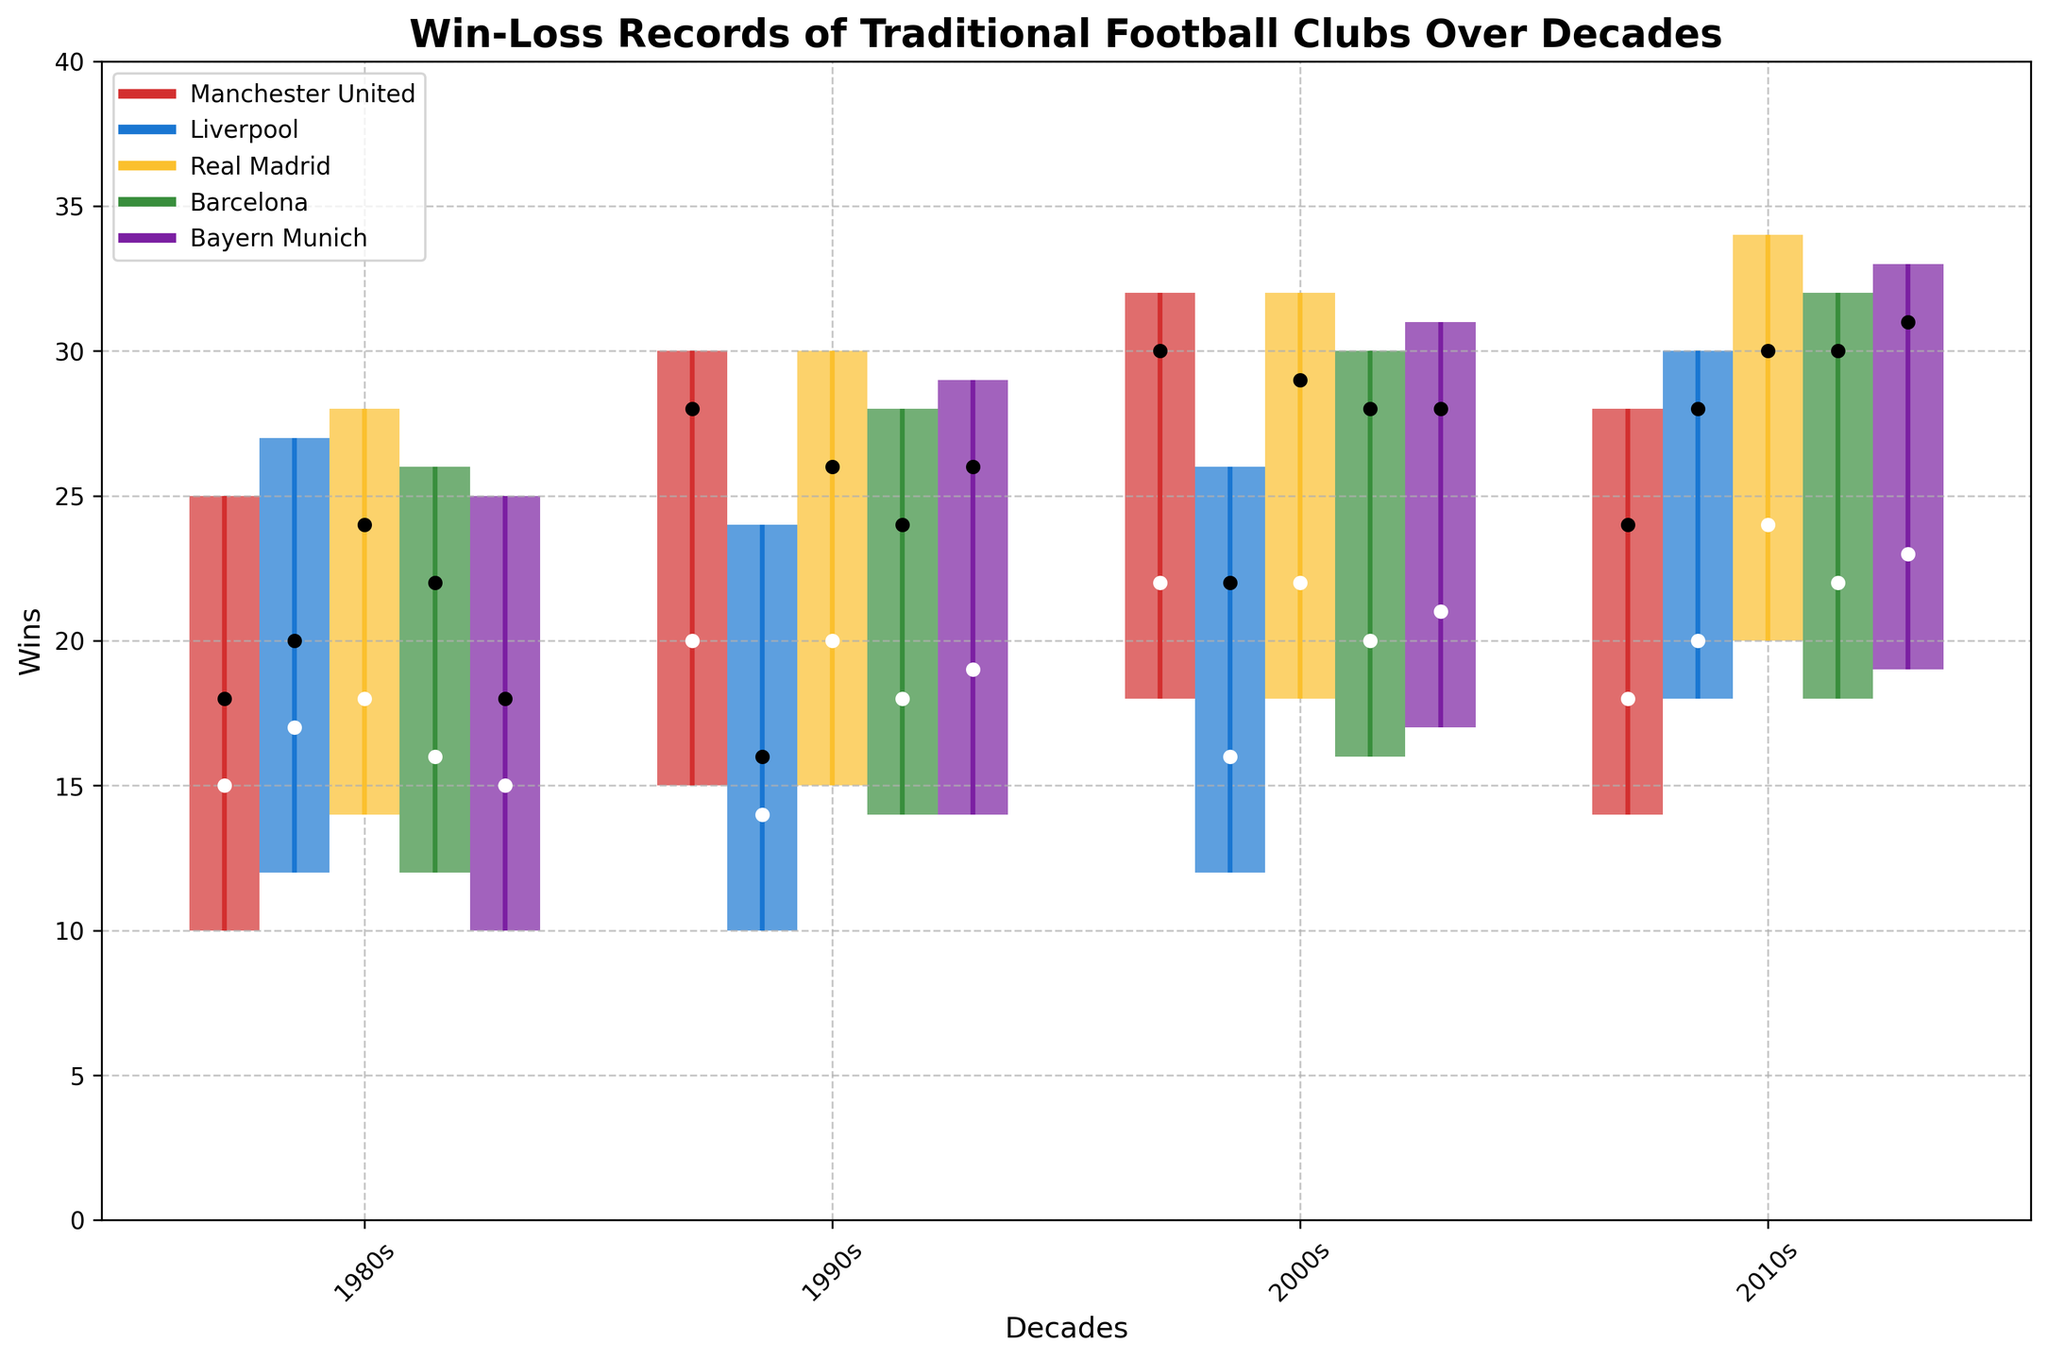What is the title of the plot? The title is typically displayed at the top of the plot, showing the main subject of the visualization. Here, it indicates that the plot is about the win-loss records of traditional football clubs over various decades.
Answer: Win-Loss Records of Traditional Football Clubs Over Decades What are the labels of the x-axis and y-axis? The x-axis label specifies the variable represented along the horizontal axis, while the y-axis label specifies the variable plotted along the vertical axis. In this case, the x-axis label indicates "Decades," and the y-axis label shows "Wins."
Answer: Decades, Wins Which club had the highest 'High' value in the 2010s? The 'High' value is typically indicated by the highest point of the vertical line for each club in the 2010s. By examining these values, we identify the highest figure among all clubs.
Answer: Bayern Munich What's the 'Close' value for Liverpool in the 1990s? The 'Close' value is represented by the horizontal bar at the end of each candlestick corresponding to the 1990s for Liverpool.
Answer: 16 Which club experienced the greatest increase in their 'Close' value from the 2000s to the 2010s? To solve this, subtract the 'Close' values of each club in the 2000s from their 'Close' values in the 2010s and identify the largest difference. Bayern Munich's 'Close' value increased from 28 in the 2000s to 31 in the 2010s, showing the greatest increase of 3.
Answer: Bayern Munich How did Manchester United's 'Open' value change from the 1980s to the 2000s? Compare the 'Open' values for Manchester United in the 1980s (15) and 2000s (22) by subtracting the 1980s value from the 2000s value. The increase is 22 - 15 = 7.
Answer: Increased by 7 Which club has the lowest 'Low' value across all decades, and what is that value? Review the 'Low' values for all clubs across all decades and identify the smallest number. The smallest 'Low' value among all clubs is 10, shared by Manchester United and Liverpool in the 1980s and 1990s.
Answer: Manchester United and Liverpool, 10 What was Real Madrid's 'Open' value in the 2010s compared to Barcelona's 'Open' value in the same decade? Look at the starting points (white circles) for both Real Madrid and Barcelona in the 2010s. Real Madrid's 'Open' value is 24, while Barcelona's is 22. Compare these figures to determine which is higher.
Answer: Real Madrid has a higher 'Open' value How many clubs had a 'High' value of 30 or more in the 2000s? Count the number of clubs with their 'High' values reaching or exceeding 30 in the 2000s. These values are noted with the uppermost marks of the candlesticks for each club. Manchester United, Real Madrid, Barcelona, and Bayern Munich had 'High' values meeting or exceeding 30 in the 2000s.
Answer: 4 